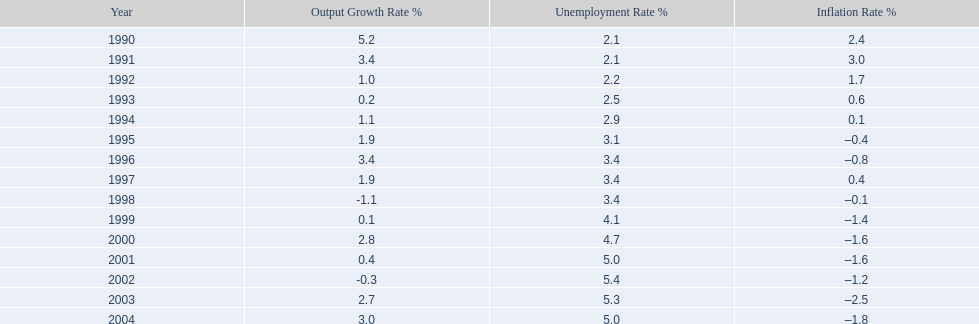Were the highest unemployment rates in japan before or after the year 2000? After. 